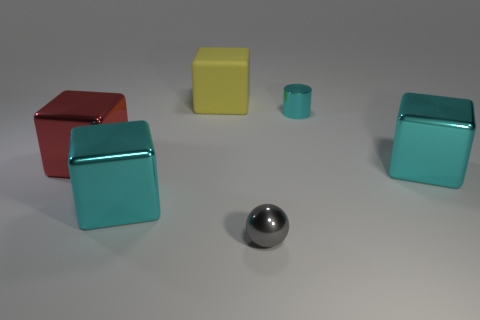Can you tell me which objects are of similar shapes? The red and the turquoise objects on the left side of the image share a similar cube-like shape, while the two cylinders, one turquoise and one smaller gray object, have similar cylindrical shapes. 